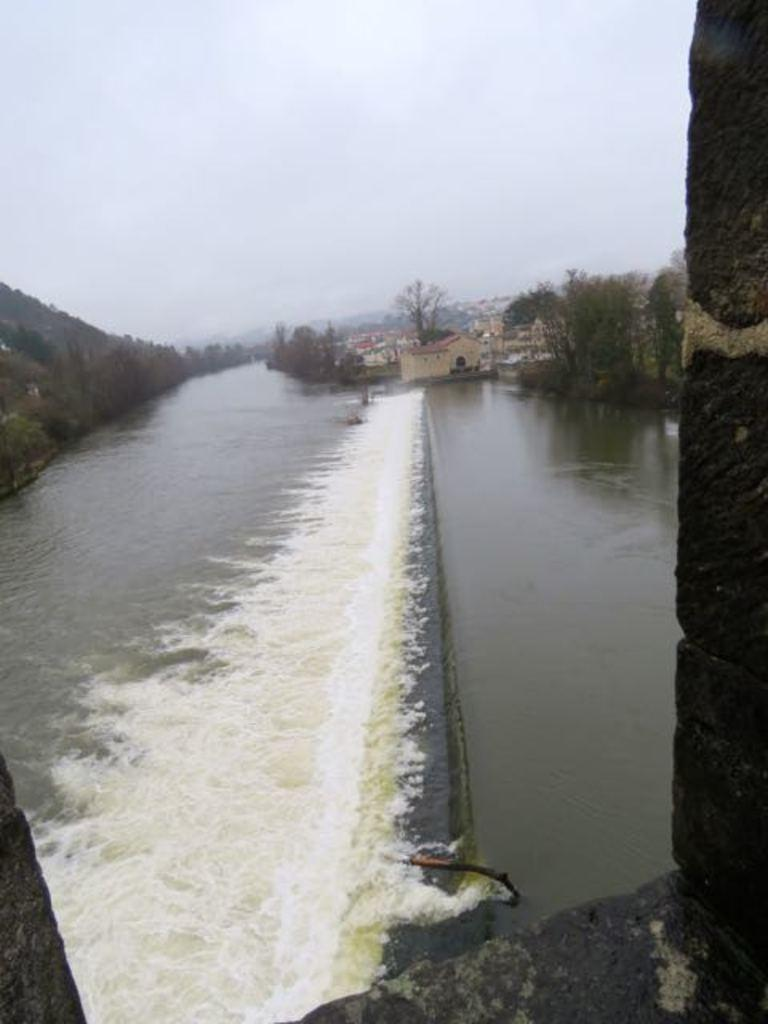What type of water feature is present in the image? There is a small river in the image. What structure can be seen behind the river? There is a small shed house behind the river. What type of vegetation is present near the river? Trees are present on both sides of the river. Where is the harbor located in the image? There is no harbor present in the image; it features a small river and a shed house. What type of clothing accessory is hanging from the trees in the image? There is no clothing accessory, such as a scarf, present in the image. 